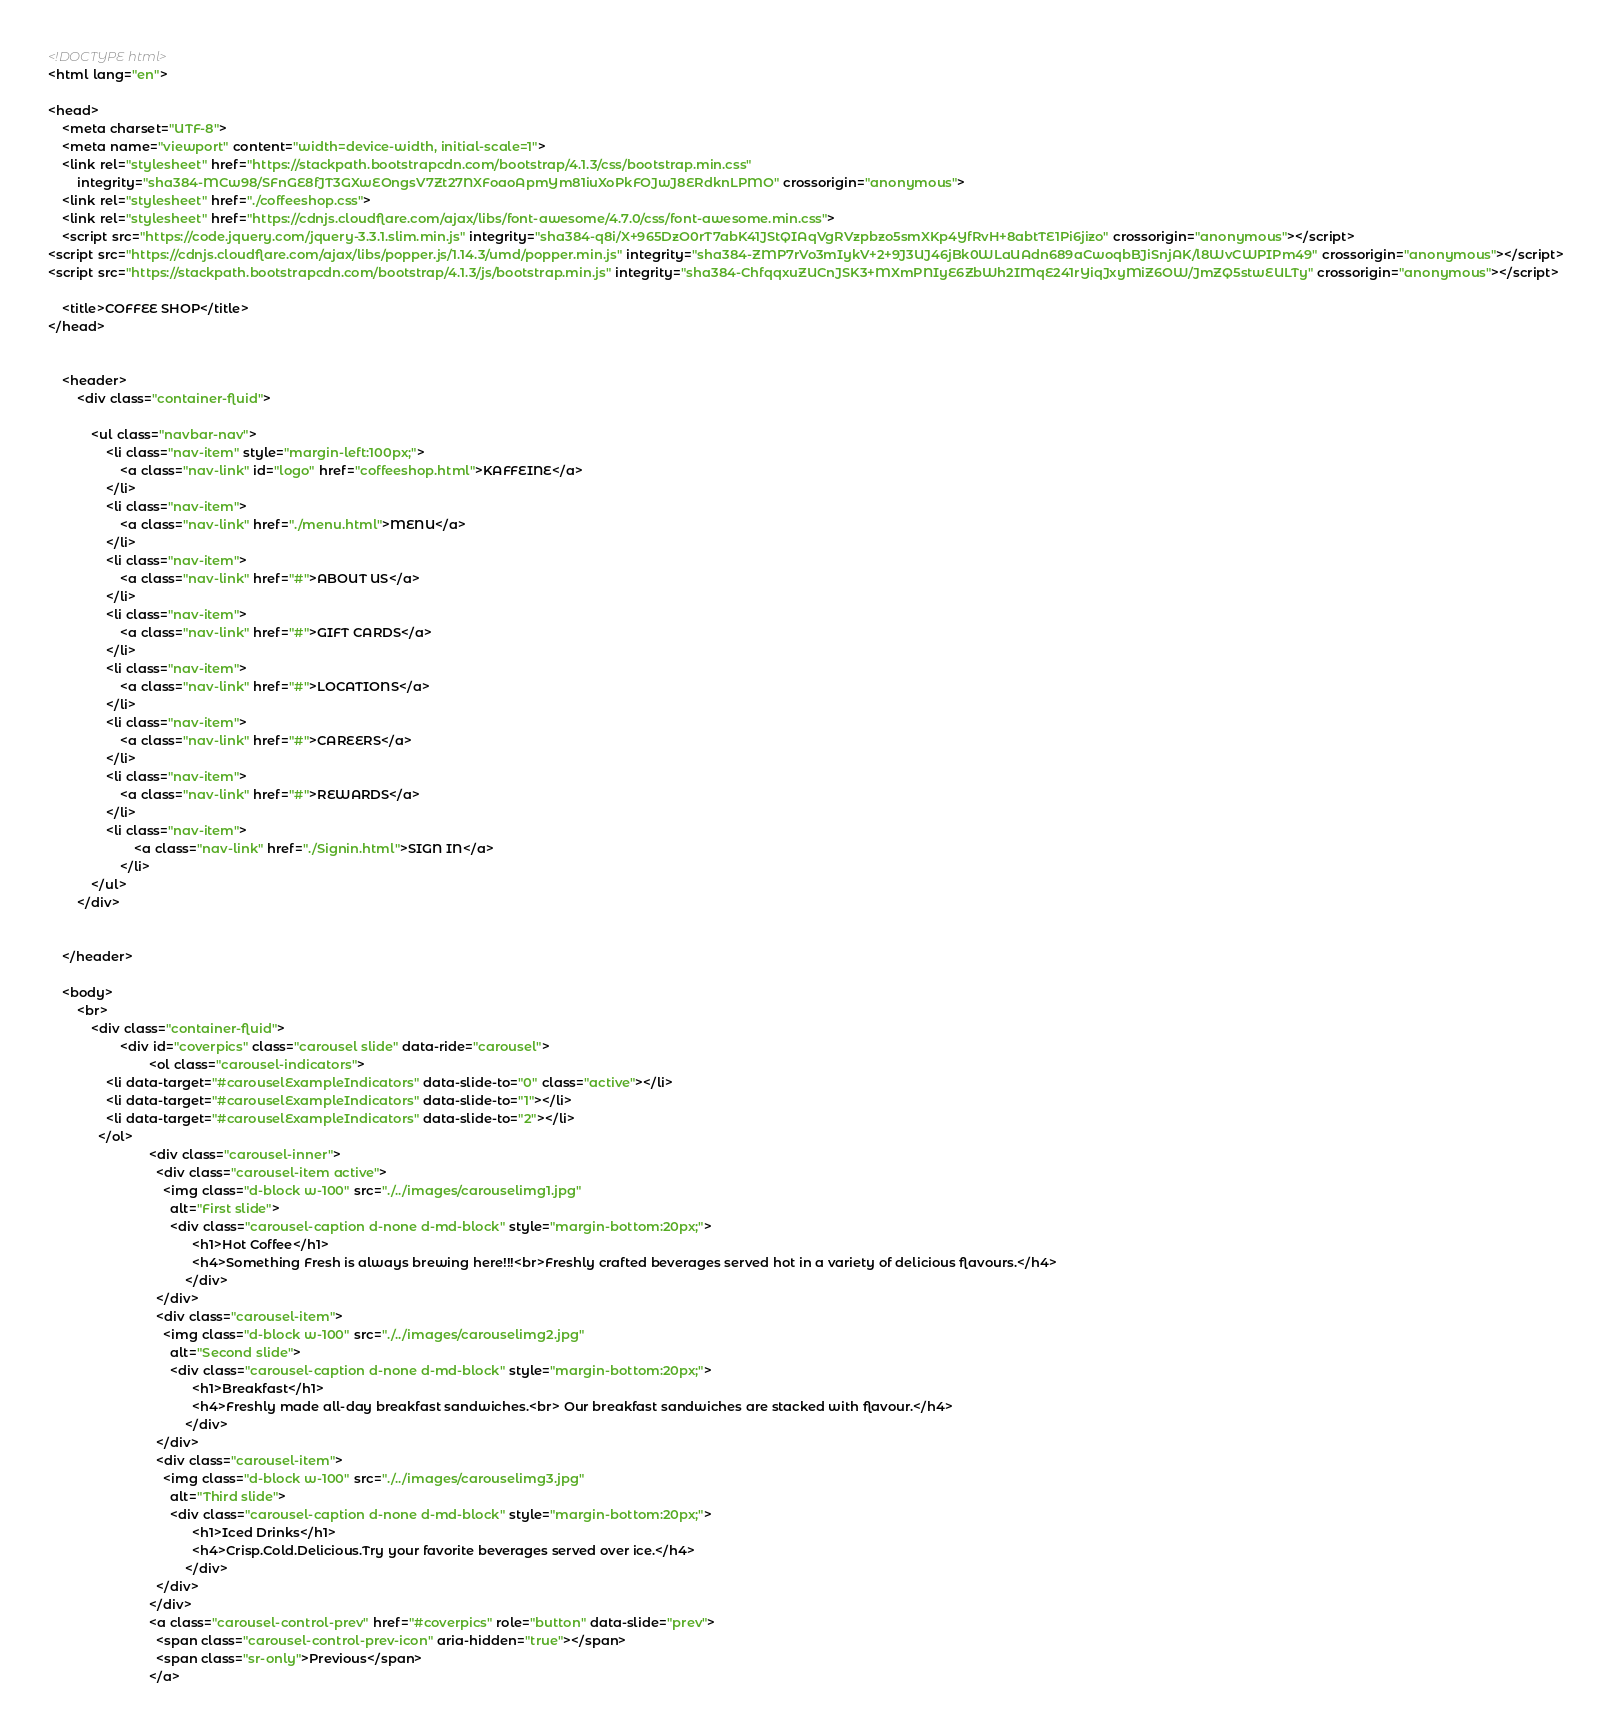<code> <loc_0><loc_0><loc_500><loc_500><_HTML_><!DOCTYPE html>
<html lang="en">

<head>
    <meta charset="UTF-8">
    <meta name="viewport" content="width=device-width, initial-scale=1">
    <link rel="stylesheet" href="https://stackpath.bootstrapcdn.com/bootstrap/4.1.3/css/bootstrap.min.css"
        integrity="sha384-MCw98/SFnGE8fJT3GXwEOngsV7Zt27NXFoaoApmYm81iuXoPkFOJwJ8ERdknLPMO" crossorigin="anonymous">
    <link rel="stylesheet" href="./coffeeshop.css">
    <link rel="stylesheet" href="https://cdnjs.cloudflare.com/ajax/libs/font-awesome/4.7.0/css/font-awesome.min.css">
    <script src="https://code.jquery.com/jquery-3.3.1.slim.min.js" integrity="sha384-q8i/X+965DzO0rT7abK41JStQIAqVgRVzpbzo5smXKp4YfRvH+8abtTE1Pi6jizo" crossorigin="anonymous"></script>
<script src="https://cdnjs.cloudflare.com/ajax/libs/popper.js/1.14.3/umd/popper.min.js" integrity="sha384-ZMP7rVo3mIykV+2+9J3UJ46jBk0WLaUAdn689aCwoqbBJiSnjAK/l8WvCWPIPm49" crossorigin="anonymous"></script>
<script src="https://stackpath.bootstrapcdn.com/bootstrap/4.1.3/js/bootstrap.min.js" integrity="sha384-ChfqqxuZUCnJSK3+MXmPNIyE6ZbWh2IMqE241rYiqJxyMiZ6OW/JmZQ5stwEULTy" crossorigin="anonymous"></script>
    
    <title>COFFEE SHOP</title>
</head>


    <header>
        <div class="container-fluid">
            
            <ul class="navbar-nav">
                <li class="nav-item" style="margin-left:100px;">
                    <a class="nav-link" id="logo" href="coffeeshop.html">KAFFEINE</a>
                </li>
                <li class="nav-item">
                    <a class="nav-link" href="./menu.html">MENU</a>
                </li>
                <li class="nav-item">
                    <a class="nav-link" href="#">ABOUT US</a>
                </li>
                <li class="nav-item">
                    <a class="nav-link" href="#">GIFT CARDS</a>
                </li>
                <li class="nav-item">
                    <a class="nav-link" href="#">LOCATIONS</a>
                </li>
                <li class="nav-item">
                    <a class="nav-link" href="#">CAREERS</a>
                </li>
                <li class="nav-item">
                    <a class="nav-link" href="#">REWARDS</a>
                </li>
                <li class="nav-item">
                        <a class="nav-link" href="./Signin.html">SIGN IN</a>
                    </li>
            </ul>
        </div>
        

    </header>

    <body>
        <br>
            <div class="container-fluid">
                    <div id="coverpics" class="carousel slide" data-ride="carousel">
                            <ol class="carousel-indicators">
                <li data-target="#carouselExampleIndicators" data-slide-to="0" class="active"></li>
                <li data-target="#carouselExampleIndicators" data-slide-to="1"></li>
                <li data-target="#carouselExampleIndicators" data-slide-to="2"></li>
              </ol>            
                            <div class="carousel-inner">
                              <div class="carousel-item active">
                                <img class="d-block w-100" src="./../images/carouselimg1.jpg"
                                  alt="First slide">
                                  <div class="carousel-caption d-none d-md-block" style="margin-bottom:20px;">
                                        <h1>Hot Coffee</h1>
                                        <h4>Something Fresh is always brewing here!!!<br>Freshly crafted beverages served hot in a variety of delicious flavours.</h4>
                                      </div>
                              </div>
                              <div class="carousel-item">
                                <img class="d-block w-100" src="./../images/carouselimg2.jpg"
                                  alt="Second slide">
                                  <div class="carousel-caption d-none d-md-block" style="margin-bottom:20px;">
                                        <h1>Breakfast</h1>
                                        <h4>Freshly made all-day breakfast sandwiches.<br> Our breakfast sandwiches are stacked with flavour.</h4>
                                      </div>
                              </div>
                              <div class="carousel-item">
                                <img class="d-block w-100" src="./../images/carouselimg3.jpg"
                                  alt="Third slide">
                                  <div class="carousel-caption d-none d-md-block" style="margin-bottom:20px;">
                                        <h1>Iced Drinks</h1>
                                        <h4>Crisp.Cold.Delicious.Try your favorite beverages served over ice.</h4>
                                      </div>
                              </div>
                            </div>
                            <a class="carousel-control-prev" href="#coverpics" role="button" data-slide="prev">
                              <span class="carousel-control-prev-icon" aria-hidden="true"></span>
                              <span class="sr-only">Previous</span>
                            </a></code> 